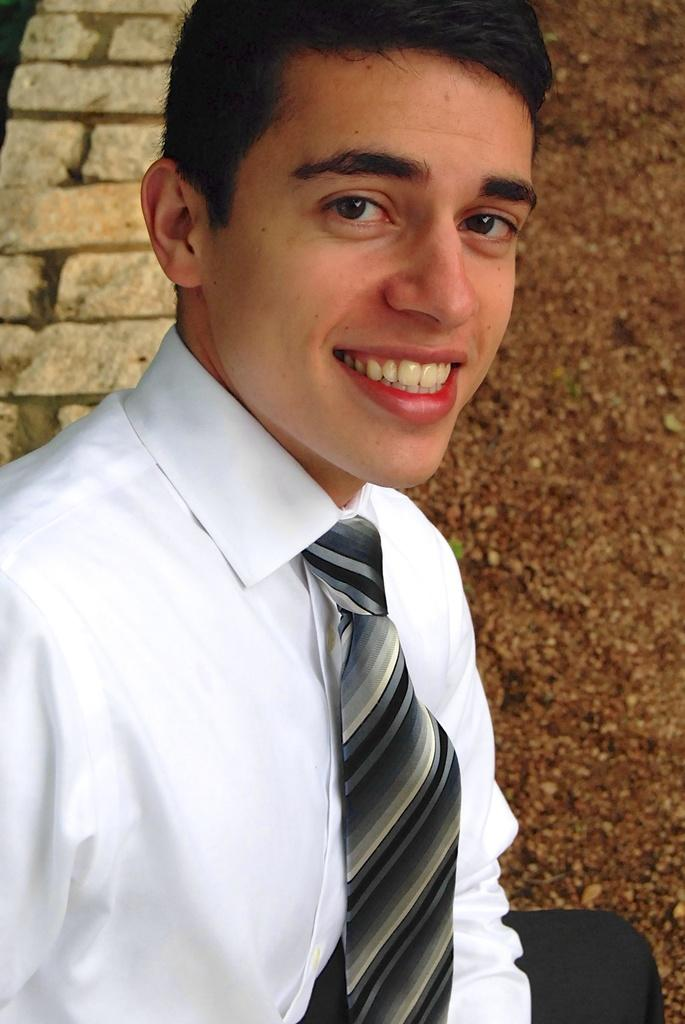What is present in the image? There is a man in the image. What color clothing is the man wearing? The man is wearing white color clothing. What accessory is the man wearing around his neck? The man is wearing a tie. What type of material can be seen in the image? There are bricks visible in the image. What type of cherry can be seen on the man's face in the image? There is no cherry present on the man's face in the image. What kind of mark is visible on the man's forehead in the image? There is no mark visible on the man's forehead in the image. 